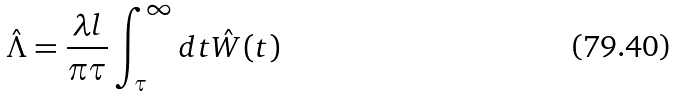<formula> <loc_0><loc_0><loc_500><loc_500>\hat { \Lambda } = \frac { \lambda l } { \pi \tau } \int _ { \tau } ^ { \infty } d t \hat { W } ( t )</formula> 